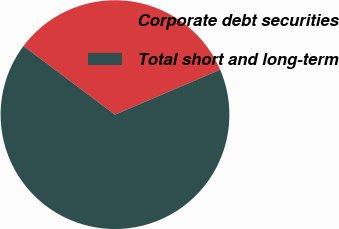<chart> <loc_0><loc_0><loc_500><loc_500><pie_chart><fcel>Corporate debt securities<fcel>Total short and long-term<nl><fcel>33.33%<fcel>66.67%<nl></chart> 